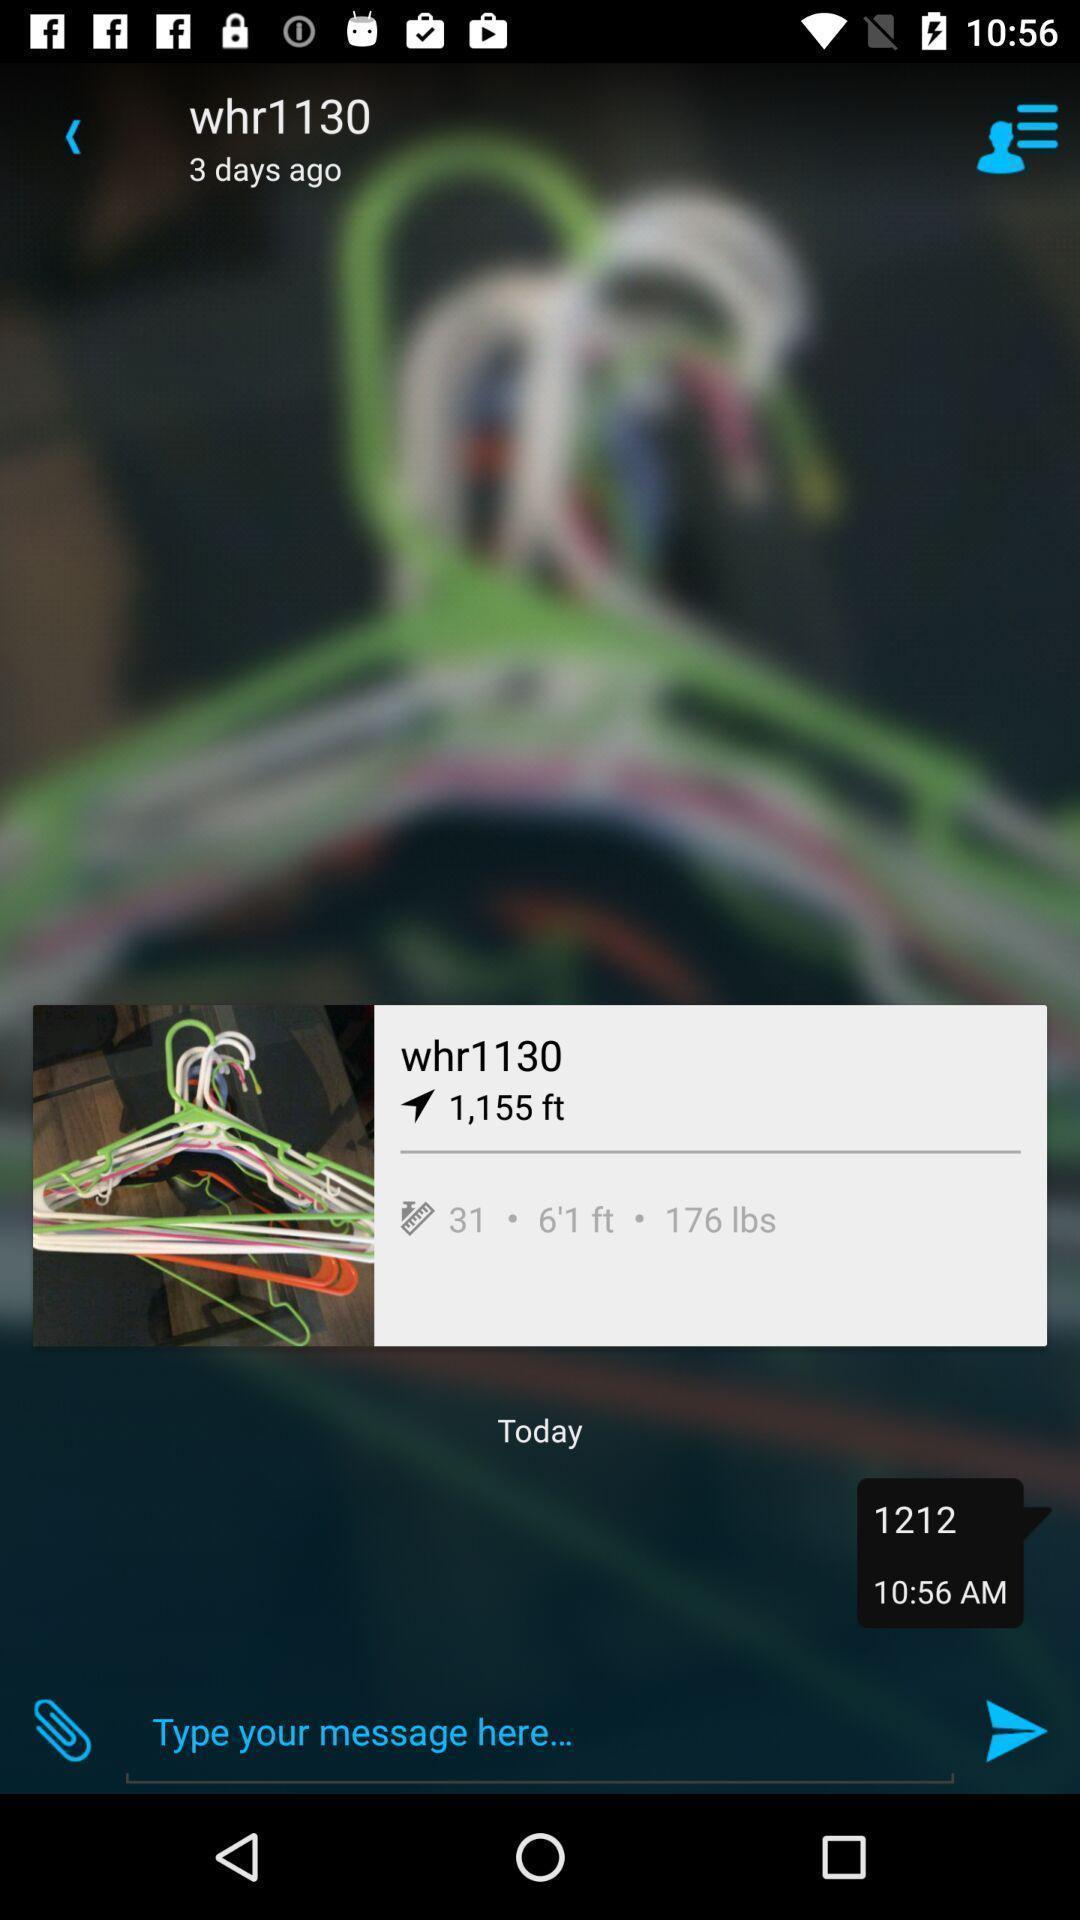Describe the visual elements of this screenshot. Screen displaying contents in message page. 